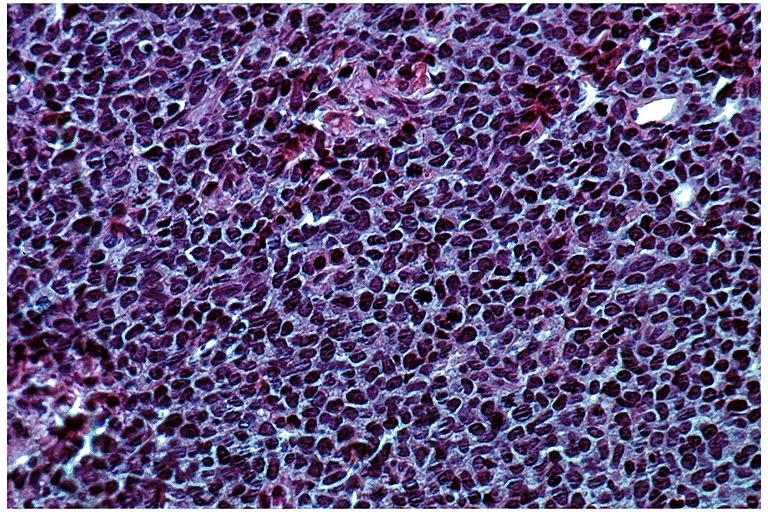s amyloidosis present?
Answer the question using a single word or phrase. No 